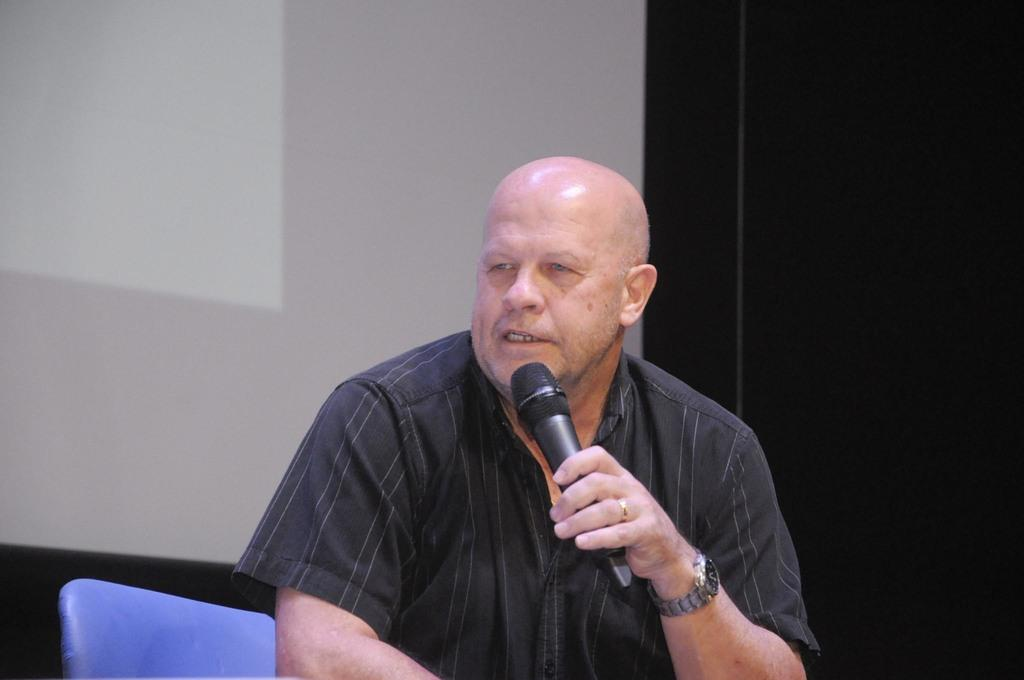What is the main subject of the image? There is a person in the image. What is the person holding in the image? The person is holding a microphone. What can be seen in the background of the image? There is a screen in the background of the image. What type of feather can be seen on the person's hat in the image? There is no feather present on the person's hat in the image. What type of sponge is being used by the person to clean the microphone in the image? There is no sponge visible in the image, and the person is not cleaning the microphone. 